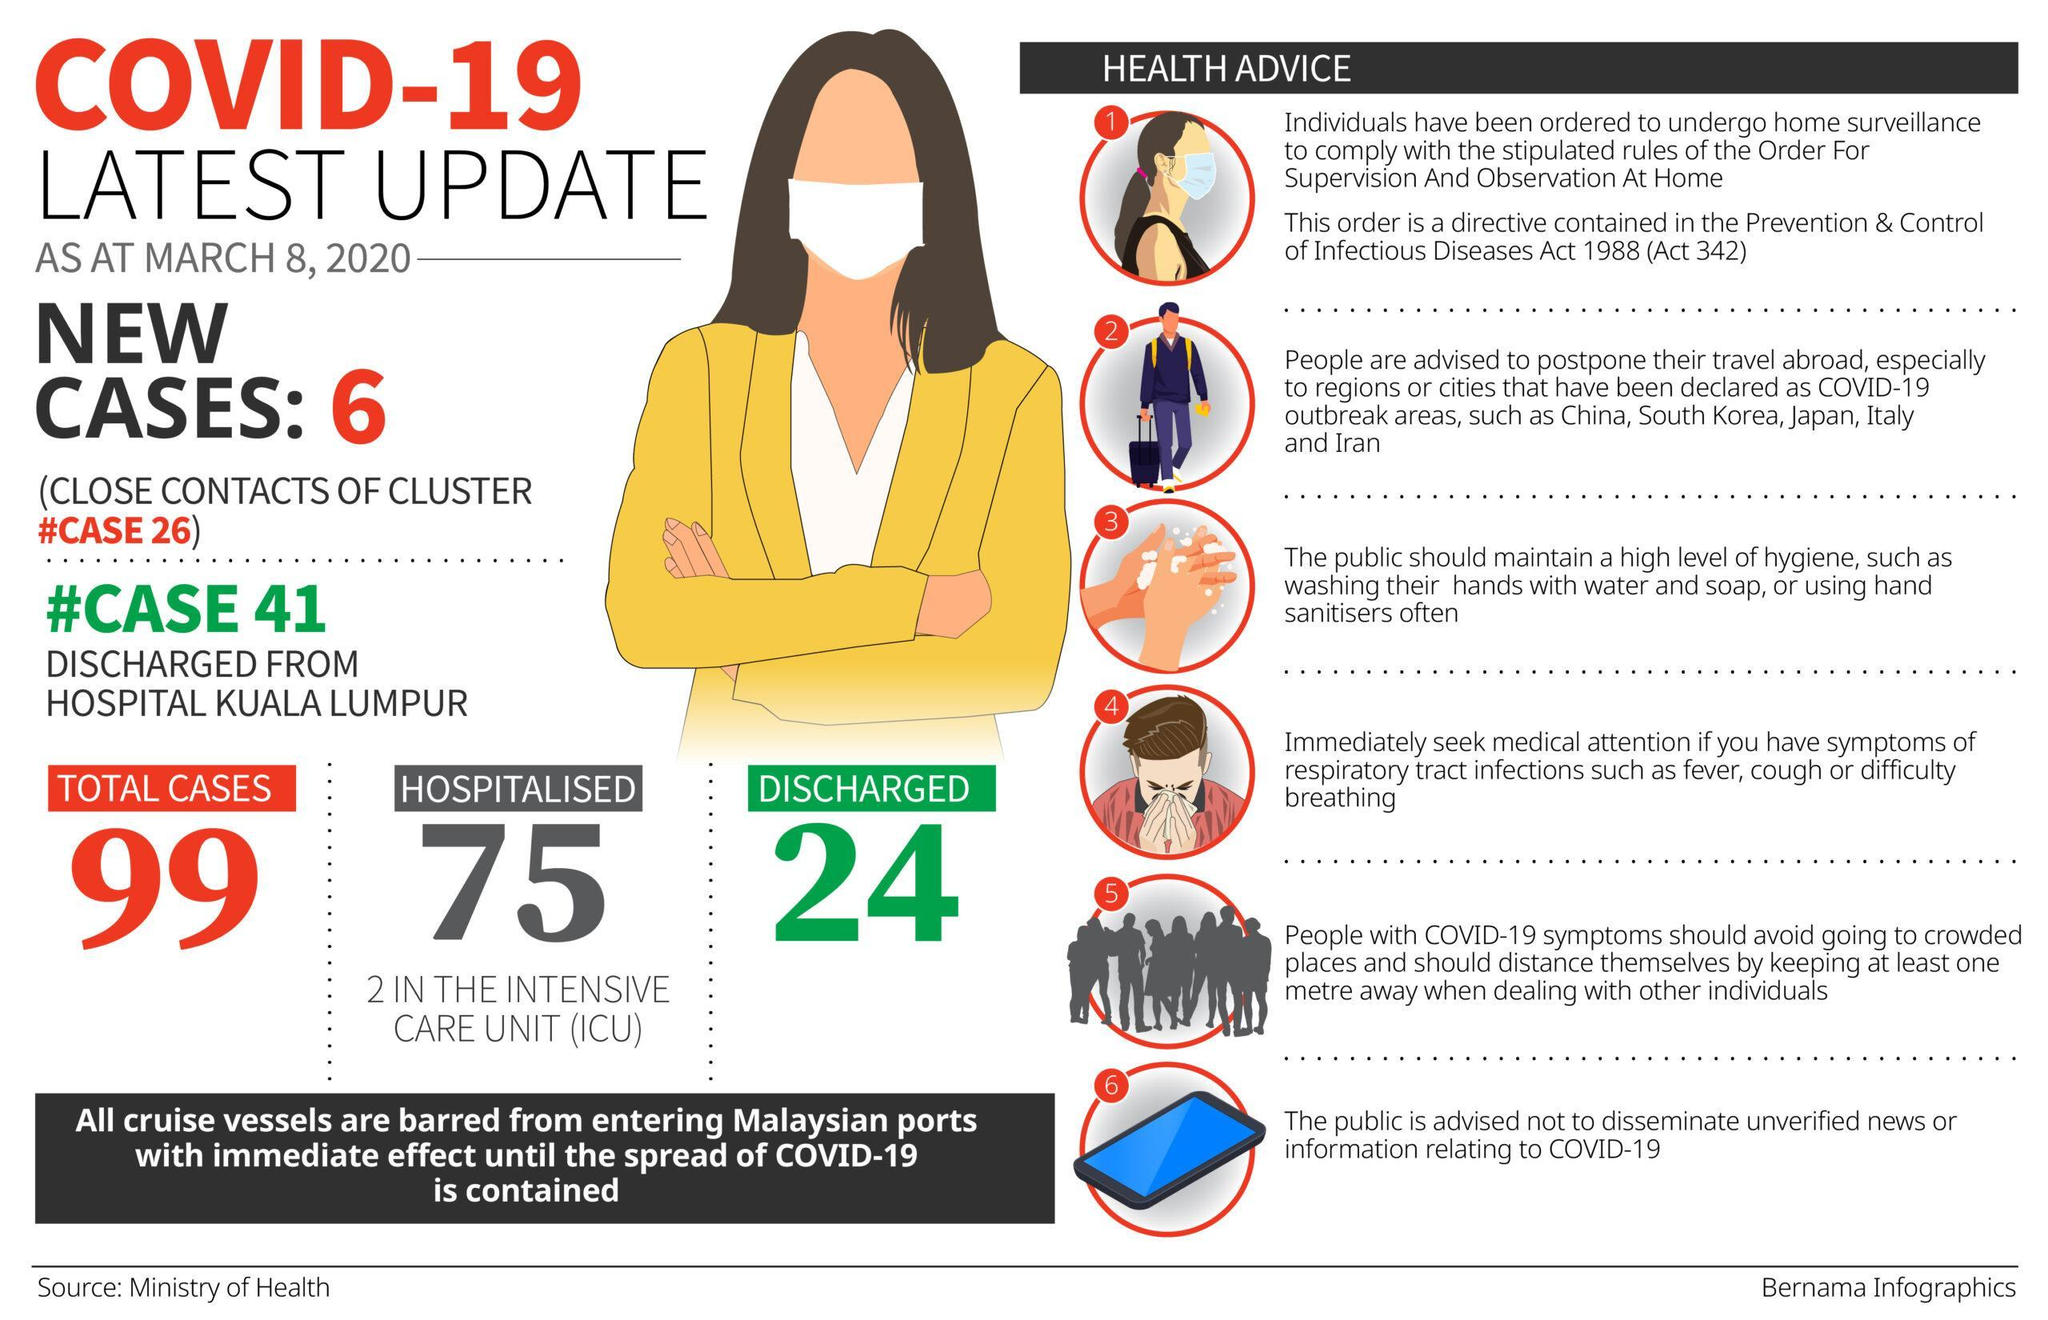How many COVID-19 patients were hospitalised in Malaysia as of March 8, 2020?
Answer the question with a short phrase. 75 What is the total number of COVID-19 cases reported in Malaysia as of March 8, 2020? 99 How many new Covid-19 cases were reported in Malaysia as of March 8, 2020? 6 How many COVID-19 cases were admitted in the ICU in Malaysia as of March 8, 2020? 2 How many recovered cases of covid-19 were reported in Malaysia as of March 8, 2020? 24 